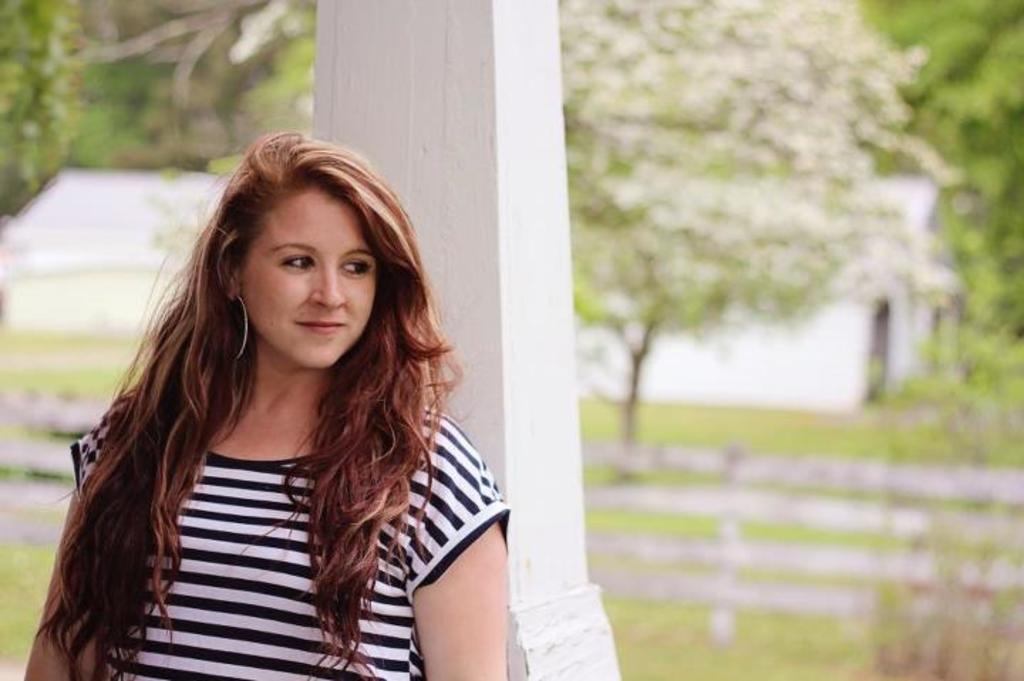How would you summarize this image in a sentence or two? In this image we can see this person wearing black and white T-shirt is smiling and standing near the white color pillar. The background of the image is blurred, where we can see the wooden fence, grass, house and trees. 